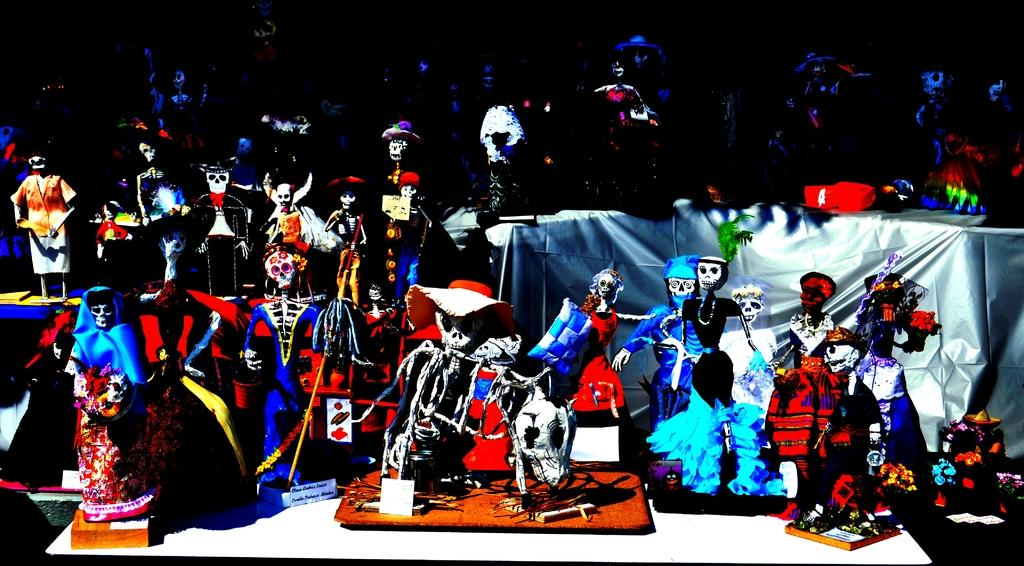What type of furniture is in the image? There are tables in the image. What is placed on the tables? Clothes, dolls, and toys are visible on the tables. What can be inferred about the lighting in the image? The background of the image is dark. What type of tool is the carpenter using in the image? There is no carpenter or tool present in the image. What type of footwear is visible on the dolls in the image? The image does not show the dolls' feet or any footwear. 